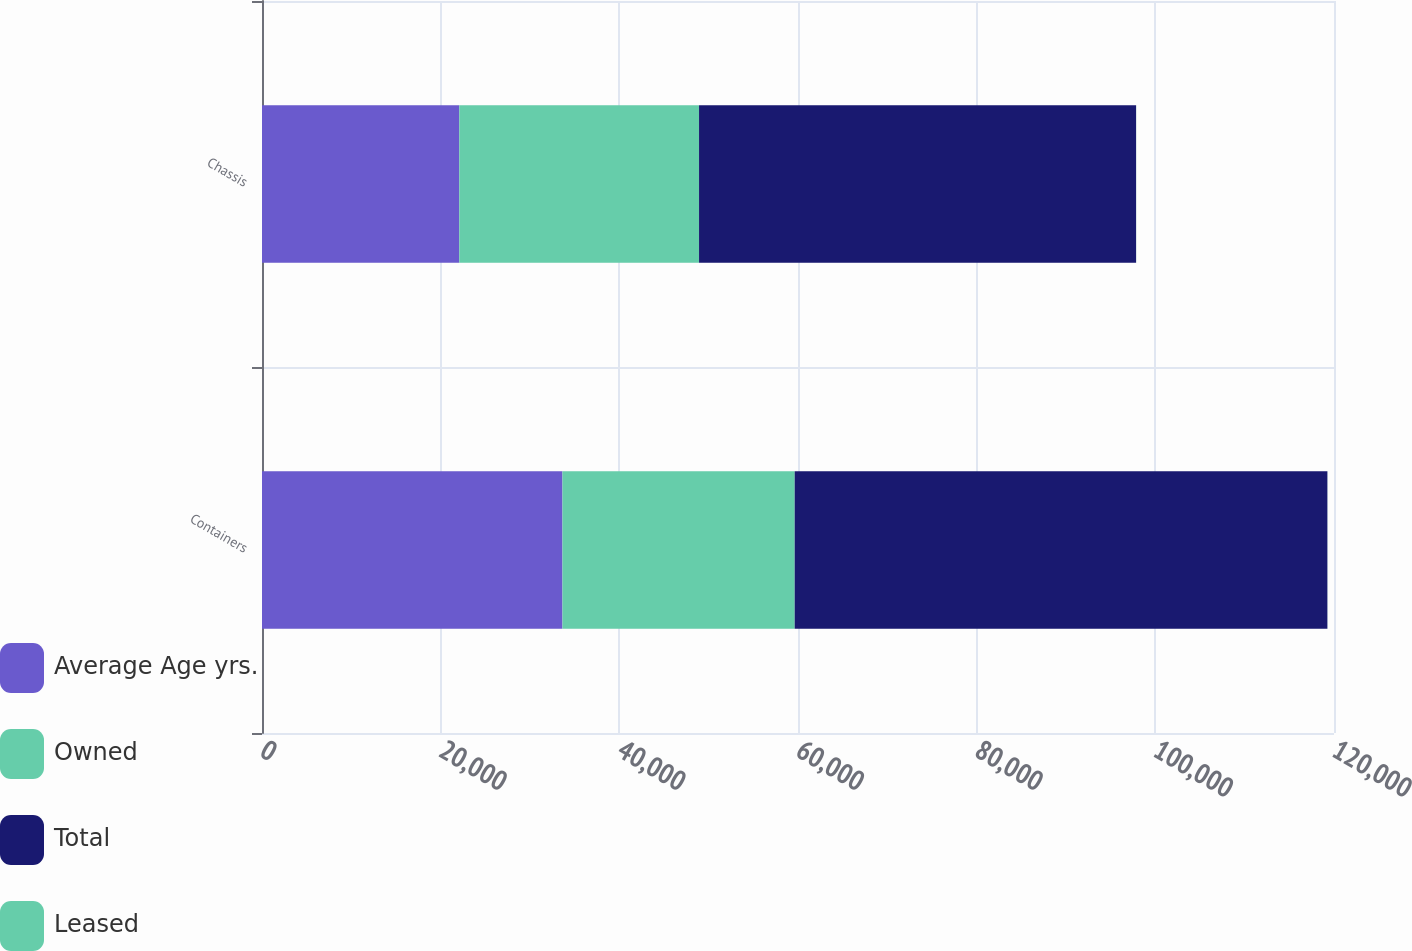Convert chart to OTSL. <chart><loc_0><loc_0><loc_500><loc_500><stacked_bar_chart><ecel><fcel>Containers<fcel>Chassis<nl><fcel>Average Age yrs.<fcel>33633<fcel>22086<nl><fcel>Owned<fcel>25998<fcel>26837<nl><fcel>Total<fcel>59631<fcel>48923<nl><fcel>Leased<fcel>8<fcel>9.6<nl></chart> 